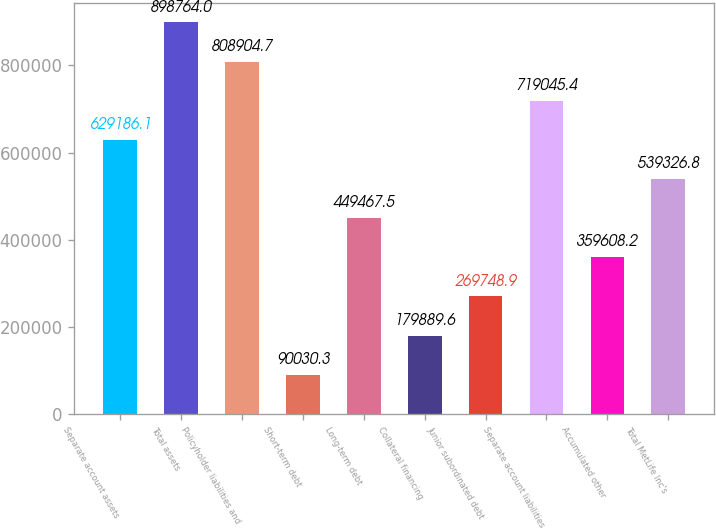<chart> <loc_0><loc_0><loc_500><loc_500><bar_chart><fcel>Separate account assets<fcel>Total assets<fcel>Policyholder liabilities and<fcel>Short-term debt<fcel>Long-term debt<fcel>Collateral financing<fcel>Junior subordinated debt<fcel>Separate account liabilities<fcel>Accumulated other<fcel>Total MetLife Inc's<nl><fcel>629186<fcel>898764<fcel>808905<fcel>90030.3<fcel>449468<fcel>179890<fcel>269749<fcel>719045<fcel>359608<fcel>539327<nl></chart> 